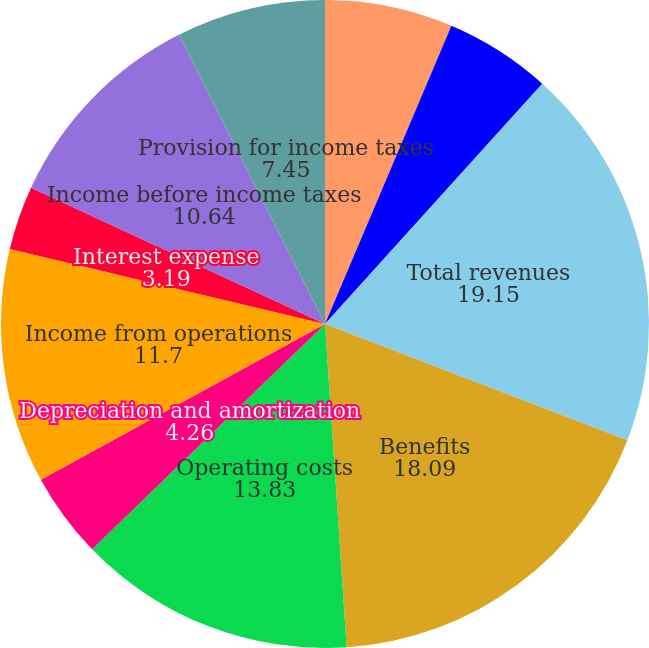Convert chart to OTSL. <chart><loc_0><loc_0><loc_500><loc_500><pie_chart><fcel>Services<fcel>Investment income<fcel>Total revenues<fcel>Benefits<fcel>Operating costs<fcel>Depreciation and amortization<fcel>Income from operations<fcel>Interest expense<fcel>Income before income taxes<fcel>Provision for income taxes<nl><fcel>6.38%<fcel>5.32%<fcel>19.15%<fcel>18.09%<fcel>13.83%<fcel>4.26%<fcel>11.7%<fcel>3.19%<fcel>10.64%<fcel>7.45%<nl></chart> 